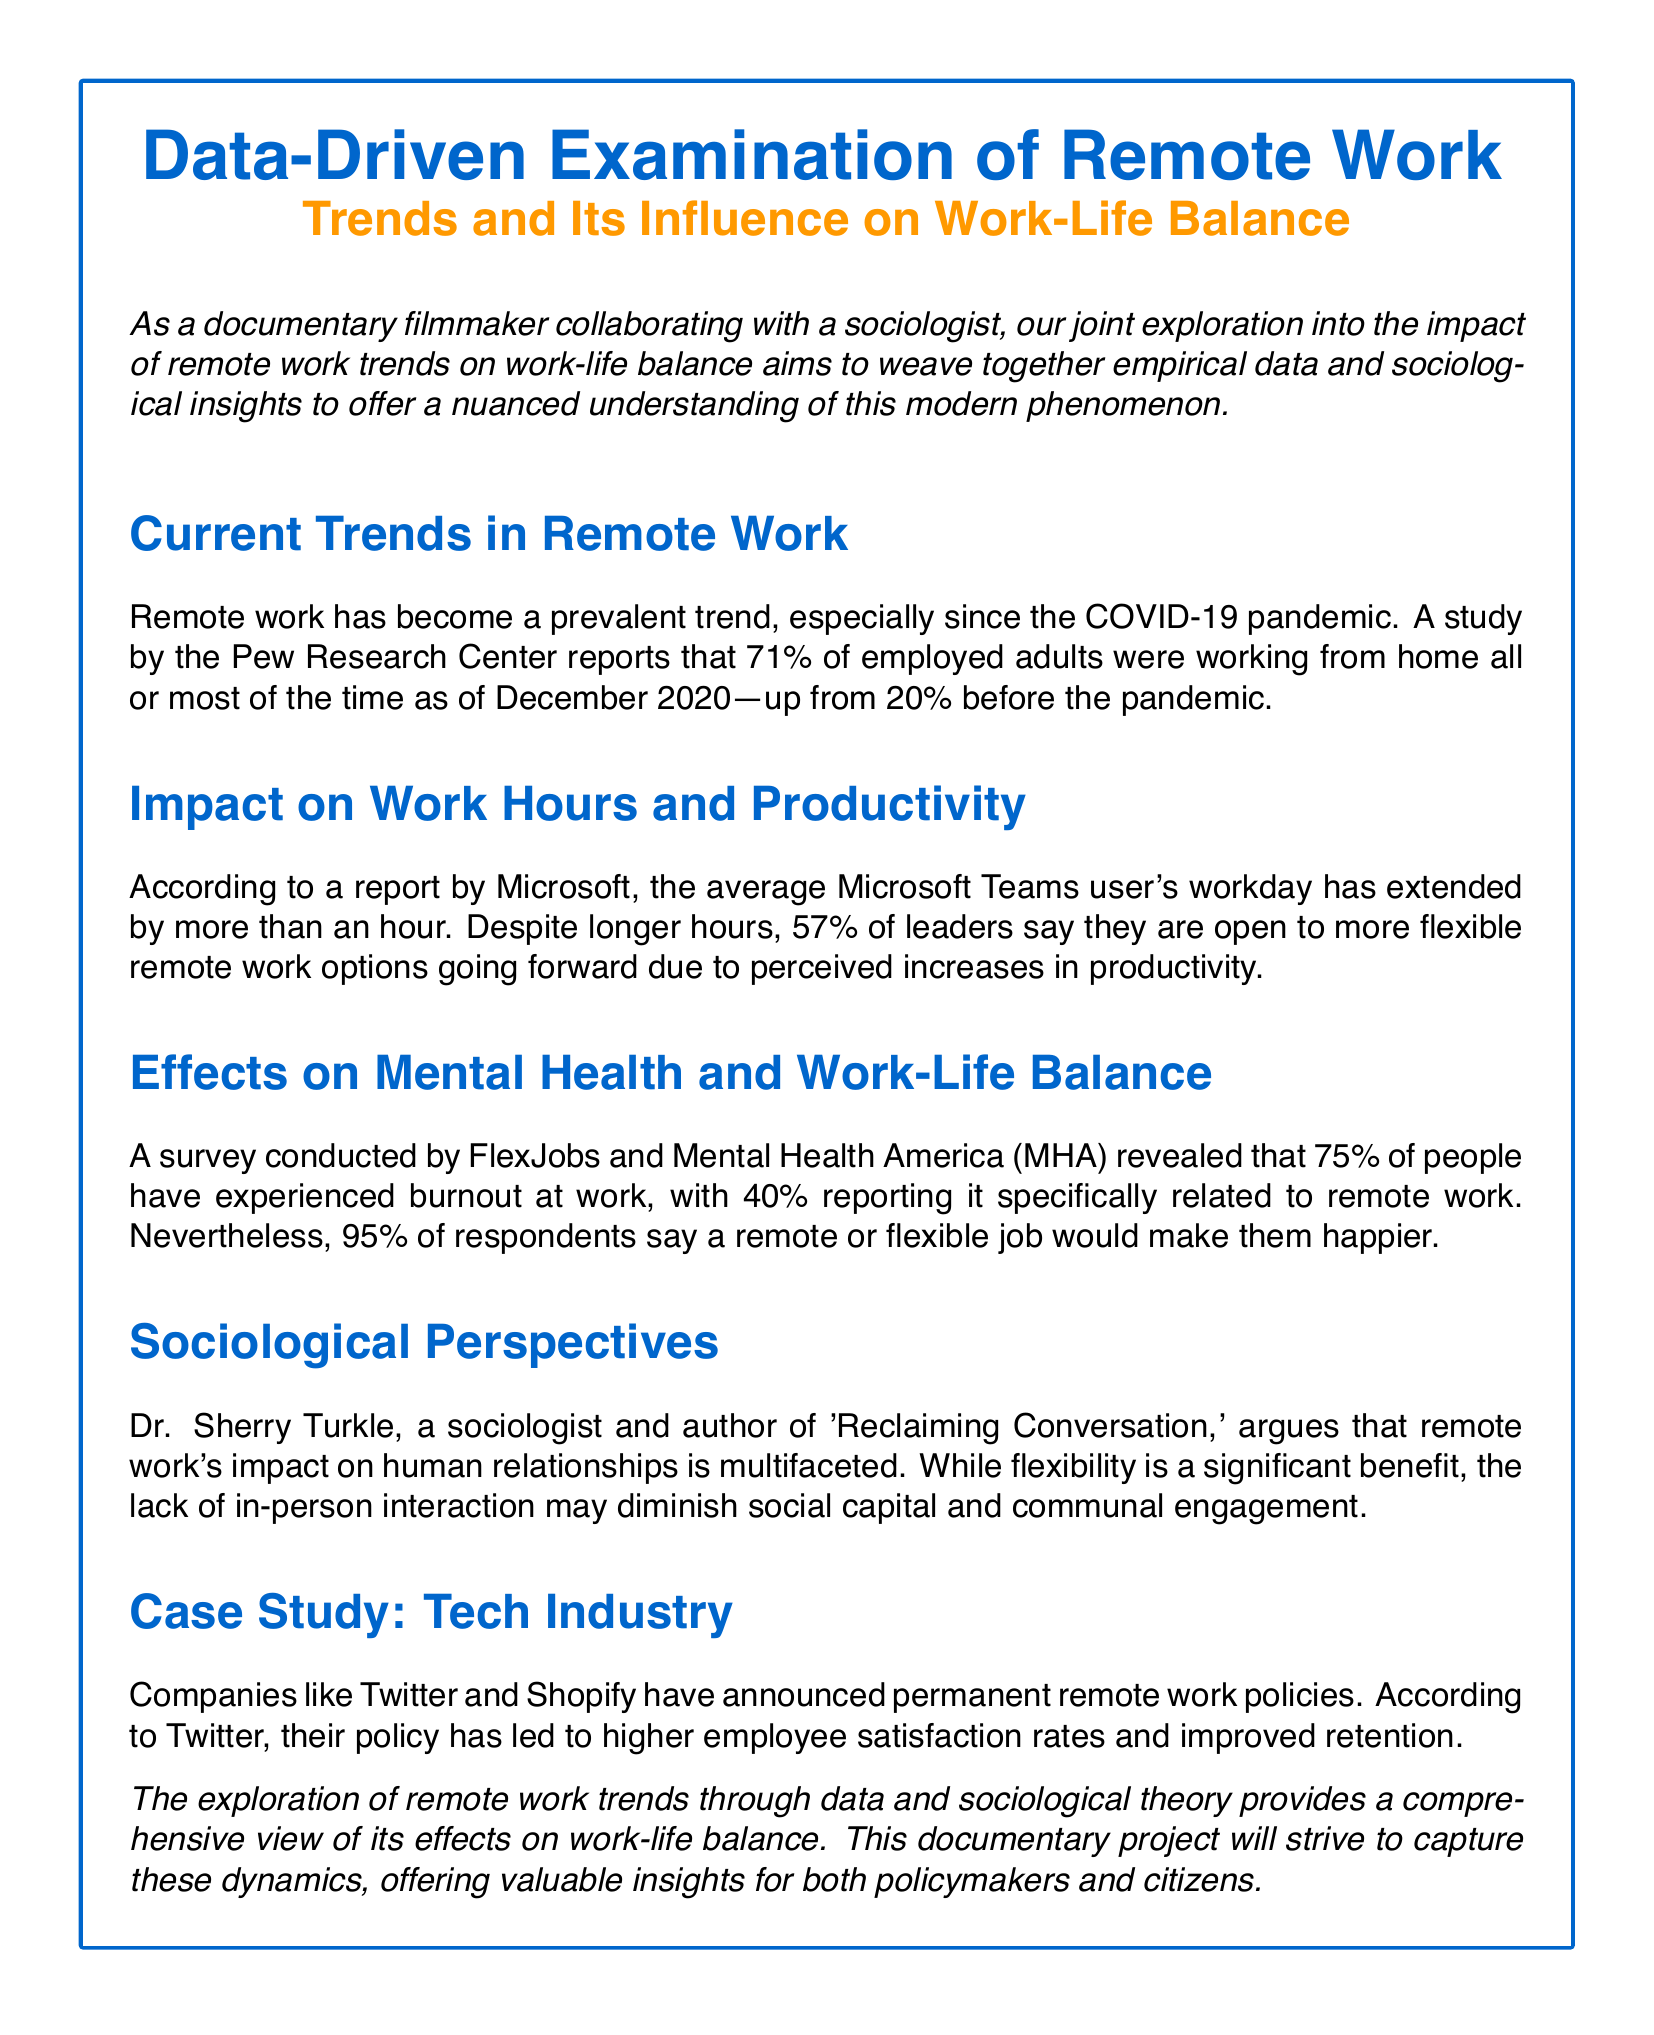what percentage of employed adults were working from home as of December 2020? The document states that 71% of employed adults were working from home all or most of the time as of December 2020.
Answer: 71% what factor contributed to the extension of the workday for Microsoft Teams users? According to the report, the average workday has extended due to more than one hour of work.
Answer: one hour what percentage of people experienced burnout related to remote work? The survey revealed that 40% reported burnout specifically related to remote work.
Answer: 40% who argues that the lack of in-person interaction may diminish social capital? Dr. Sherry Turkle is mentioned as arguing about the impact of remote work on human relationships.
Answer: Dr. Sherry Turkle which companies announced permanent remote work policies? The document mentions Twitter and Shopify as companies that announced permanent remote work policies.
Answer: Twitter and Shopify how many leaders believe in more flexible remote work options? According to the Microsoft report, 57% of leaders are open to more flexible remote work options.
Answer: 57% what is the overall sentiment towards remote or flexible jobs according to the survey? The survey indicates that 95% of respondents believe that a remote or flexible job would make them happier.
Answer: 95% what is the main focus of the documentary project? The documentary project aims to capture the dynamics of remote work trends and their effects on work-life balance.
Answer: work-life balance 